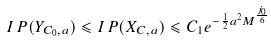<formula> <loc_0><loc_0><loc_500><loc_500>I \, P ( Y _ { C _ { 0 } , a } ) \leqslant I \, P ( X _ { C , a } ) \leqslant C _ { 1 } e ^ { - \frac { 1 } { 2 } a ^ { 2 } M ^ { \frac { j _ { 0 } } { 6 } } }</formula> 